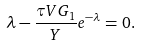Convert formula to latex. <formula><loc_0><loc_0><loc_500><loc_500>\lambda - \frac { \tau V G _ { 1 } } { Y } e ^ { - \lambda } = 0 .</formula> 